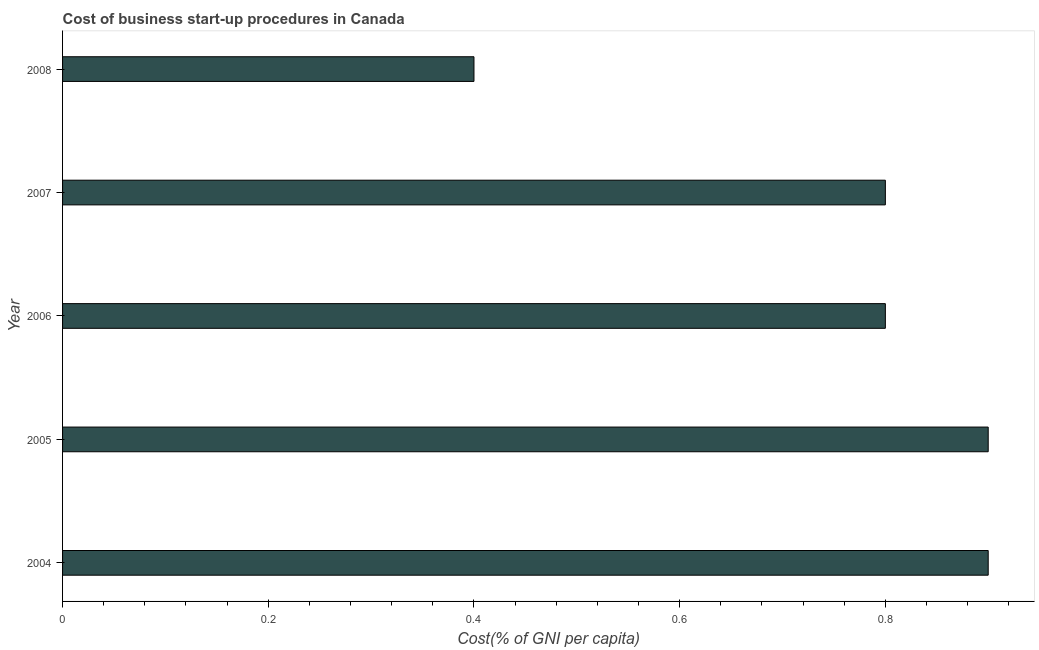Does the graph contain any zero values?
Make the answer very short. No. Does the graph contain grids?
Give a very brief answer. No. What is the title of the graph?
Provide a short and direct response. Cost of business start-up procedures in Canada. What is the label or title of the X-axis?
Your answer should be very brief. Cost(% of GNI per capita). What is the label or title of the Y-axis?
Your answer should be very brief. Year. What is the cost of business startup procedures in 2008?
Your answer should be compact. 0.4. Across all years, what is the minimum cost of business startup procedures?
Offer a very short reply. 0.4. In which year was the cost of business startup procedures minimum?
Give a very brief answer. 2008. What is the sum of the cost of business startup procedures?
Your answer should be compact. 3.8. What is the average cost of business startup procedures per year?
Keep it short and to the point. 0.76. In how many years, is the cost of business startup procedures greater than 0.6 %?
Your answer should be compact. 4. Do a majority of the years between 2004 and 2005 (inclusive) have cost of business startup procedures greater than 0.12 %?
Ensure brevity in your answer.  Yes. Is the cost of business startup procedures in 2005 less than that in 2008?
Provide a short and direct response. No. Is the difference between the cost of business startup procedures in 2004 and 2006 greater than the difference between any two years?
Your answer should be compact. No. What is the difference between the highest and the second highest cost of business startup procedures?
Make the answer very short. 0. What is the difference between the highest and the lowest cost of business startup procedures?
Provide a succinct answer. 0.5. How many years are there in the graph?
Your answer should be compact. 5. What is the difference between two consecutive major ticks on the X-axis?
Offer a very short reply. 0.2. Are the values on the major ticks of X-axis written in scientific E-notation?
Make the answer very short. No. What is the Cost(% of GNI per capita) in 2006?
Make the answer very short. 0.8. What is the Cost(% of GNI per capita) of 2007?
Your answer should be compact. 0.8. What is the Cost(% of GNI per capita) of 2008?
Your answer should be compact. 0.4. What is the difference between the Cost(% of GNI per capita) in 2004 and 2008?
Provide a succinct answer. 0.5. What is the difference between the Cost(% of GNI per capita) in 2005 and 2007?
Make the answer very short. 0.1. What is the difference between the Cost(% of GNI per capita) in 2005 and 2008?
Give a very brief answer. 0.5. What is the difference between the Cost(% of GNI per capita) in 2006 and 2007?
Offer a terse response. 0. What is the ratio of the Cost(% of GNI per capita) in 2004 to that in 2005?
Provide a short and direct response. 1. What is the ratio of the Cost(% of GNI per capita) in 2004 to that in 2006?
Your answer should be very brief. 1.12. What is the ratio of the Cost(% of GNI per capita) in 2004 to that in 2008?
Your answer should be very brief. 2.25. What is the ratio of the Cost(% of GNI per capita) in 2005 to that in 2007?
Offer a terse response. 1.12. What is the ratio of the Cost(% of GNI per capita) in 2005 to that in 2008?
Your answer should be compact. 2.25. What is the ratio of the Cost(% of GNI per capita) in 2006 to that in 2007?
Give a very brief answer. 1. What is the ratio of the Cost(% of GNI per capita) in 2006 to that in 2008?
Offer a very short reply. 2. 